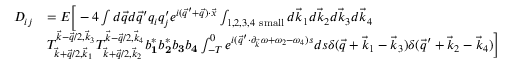Convert formula to latex. <formula><loc_0><loc_0><loc_500><loc_500>\begin{array} { r l } { D _ { i j } } & { = E \left [ - 4 \int d \vec { q } d \vec { q } ^ { \prime } q _ { i } q _ { j } ^ { \prime } e ^ { i ( \vec { q } ^ { \prime } + \vec { q } ) \cdot \vec { x } } \int _ { 1 , 2 , 3 , 4 s m a l l } d \vec { k } _ { 1 } d \vec { k } _ { 2 } d \vec { k } _ { 3 } d \vec { k } _ { 4 } } \\ & { T _ { \vec { k } + \vec { q } / 2 , \vec { k } _ { 1 } } ^ { \vec { k } - \vec { q } / 2 , \vec { k } _ { 3 } } T _ { \vec { k } + \vec { q } / 2 , \vec { k } _ { 2 } } ^ { \vec { k } - \vec { q } / 2 , \vec { k } _ { 4 } } b _ { \mathbf 1 } ^ { * } b _ { \mathbf 2 } ^ { * } b _ { \mathbf 3 } b _ { \mathbf 4 } \int _ { - T } ^ { 0 } e ^ { i ( \vec { q } ^ { \prime } \cdot \partial _ { \vec { k } } \omega + \omega _ { 2 } - \omega _ { 4 } ) s } d s \delta ( \vec { q } + \vec { k } _ { 1 } - \vec { k } _ { 3 } ) \delta ( \vec { q } ^ { \prime } + \vec { k } _ { 2 } - \vec { k } _ { 4 } ) \right ] } \end{array}</formula> 